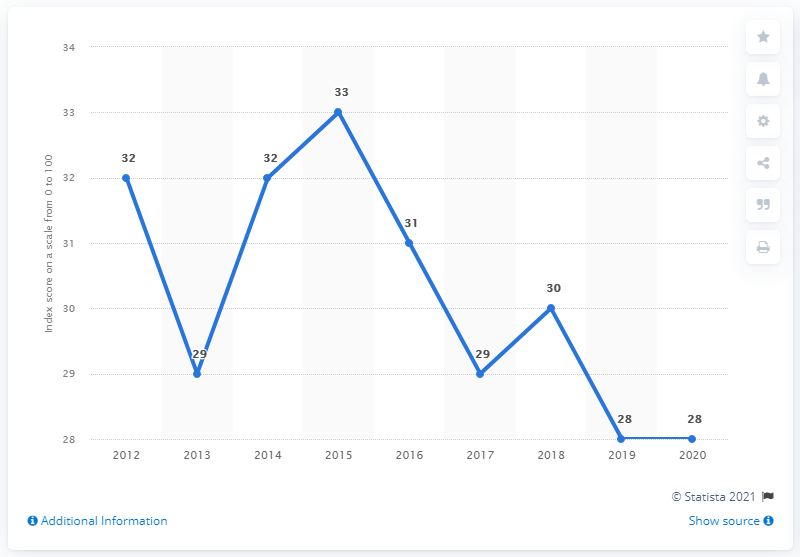What could be some of the factors contributing to the dip in the index score in 2019 and 2020 for the Dominican Republic? Several factors could be contributing to the dip in the Corruption Perception Index score for the Dominican Republic during 2019 and 2020. These may include political instability, insufficient anti-corruption legislation, lack of enforcement of existing laws, or perhaps scandals and revelations at that time which negatively influenced perceptions. It's important to examine domestic events and international pressure during these years for a more comprehensive understanding. 